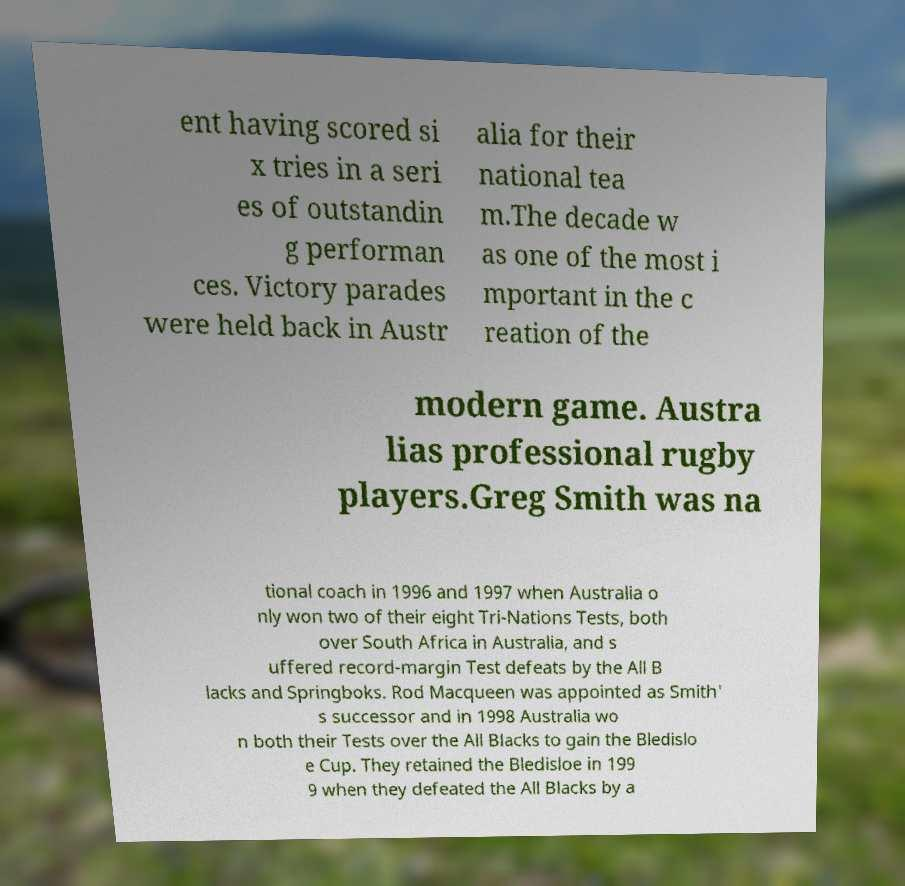Please identify and transcribe the text found in this image. ent having scored si x tries in a seri es of outstandin g performan ces. Victory parades were held back in Austr alia for their national tea m.The decade w as one of the most i mportant in the c reation of the modern game. Austra lias professional rugby players.Greg Smith was na tional coach in 1996 and 1997 when Australia o nly won two of their eight Tri-Nations Tests, both over South Africa in Australia, and s uffered record-margin Test defeats by the All B lacks and Springboks. Rod Macqueen was appointed as Smith' s successor and in 1998 Australia wo n both their Tests over the All Blacks to gain the Bledislo e Cup. They retained the Bledisloe in 199 9 when they defeated the All Blacks by a 